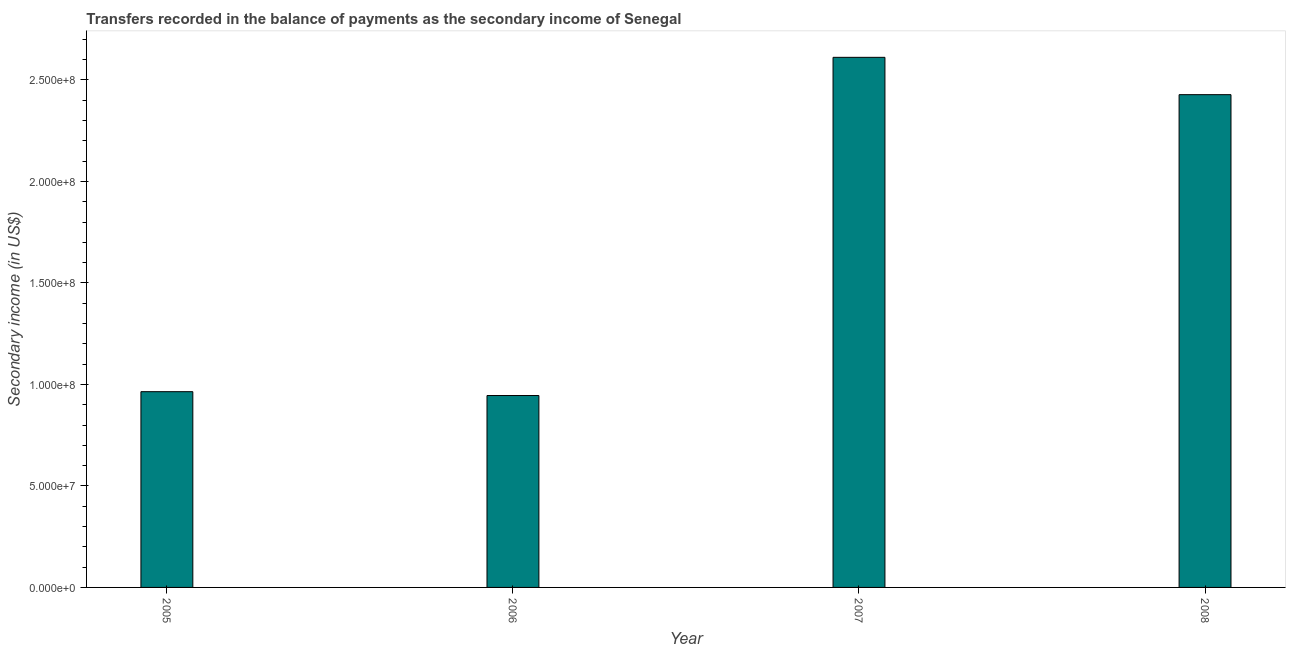Does the graph contain any zero values?
Give a very brief answer. No. What is the title of the graph?
Provide a short and direct response. Transfers recorded in the balance of payments as the secondary income of Senegal. What is the label or title of the Y-axis?
Your answer should be very brief. Secondary income (in US$). What is the amount of secondary income in 2007?
Give a very brief answer. 2.61e+08. Across all years, what is the maximum amount of secondary income?
Offer a very short reply. 2.61e+08. Across all years, what is the minimum amount of secondary income?
Offer a terse response. 9.45e+07. In which year was the amount of secondary income minimum?
Ensure brevity in your answer.  2006. What is the sum of the amount of secondary income?
Make the answer very short. 6.95e+08. What is the difference between the amount of secondary income in 2005 and 2007?
Offer a terse response. -1.65e+08. What is the average amount of secondary income per year?
Your answer should be very brief. 1.74e+08. What is the median amount of secondary income?
Give a very brief answer. 1.70e+08. Do a majority of the years between 2008 and 2007 (inclusive) have amount of secondary income greater than 260000000 US$?
Your response must be concise. No. What is the ratio of the amount of secondary income in 2005 to that in 2006?
Offer a terse response. 1.02. What is the difference between the highest and the second highest amount of secondary income?
Give a very brief answer. 1.84e+07. What is the difference between the highest and the lowest amount of secondary income?
Offer a very short reply. 1.67e+08. Are all the bars in the graph horizontal?
Offer a very short reply. No. How many years are there in the graph?
Provide a short and direct response. 4. What is the difference between two consecutive major ticks on the Y-axis?
Give a very brief answer. 5.00e+07. What is the Secondary income (in US$) in 2005?
Offer a very short reply. 9.64e+07. What is the Secondary income (in US$) of 2006?
Make the answer very short. 9.45e+07. What is the Secondary income (in US$) of 2007?
Offer a terse response. 2.61e+08. What is the Secondary income (in US$) of 2008?
Your answer should be very brief. 2.43e+08. What is the difference between the Secondary income (in US$) in 2005 and 2006?
Offer a very short reply. 1.89e+06. What is the difference between the Secondary income (in US$) in 2005 and 2007?
Keep it short and to the point. -1.65e+08. What is the difference between the Secondary income (in US$) in 2005 and 2008?
Your answer should be very brief. -1.46e+08. What is the difference between the Secondary income (in US$) in 2006 and 2007?
Keep it short and to the point. -1.67e+08. What is the difference between the Secondary income (in US$) in 2006 and 2008?
Provide a succinct answer. -1.48e+08. What is the difference between the Secondary income (in US$) in 2007 and 2008?
Your answer should be very brief. 1.84e+07. What is the ratio of the Secondary income (in US$) in 2005 to that in 2006?
Your answer should be compact. 1.02. What is the ratio of the Secondary income (in US$) in 2005 to that in 2007?
Your answer should be compact. 0.37. What is the ratio of the Secondary income (in US$) in 2005 to that in 2008?
Offer a terse response. 0.4. What is the ratio of the Secondary income (in US$) in 2006 to that in 2007?
Ensure brevity in your answer.  0.36. What is the ratio of the Secondary income (in US$) in 2006 to that in 2008?
Offer a very short reply. 0.39. What is the ratio of the Secondary income (in US$) in 2007 to that in 2008?
Your answer should be compact. 1.08. 